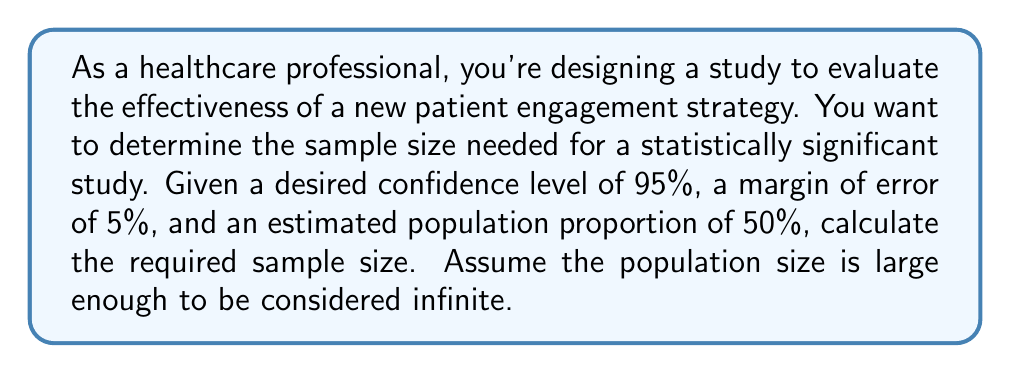Could you help me with this problem? To determine the sample size for a statistically significant study, we'll use the formula:

$$n = \frac{z^2 * p(1-p)}{e^2}$$

Where:
$n$ = sample size
$z$ = z-score (based on confidence level)
$p$ = estimated population proportion
$e$ = margin of error

Step 1: Determine the z-score for a 95% confidence level.
For 95% confidence, $z = 1.96$

Step 2: Convert the margin of error to a decimal.
$e = 5\% = 0.05$

Step 3: Use the estimated population proportion.
$p = 50\% = 0.5$

Step 4: Plug the values into the formula:

$$n = \frac{1.96^2 * 0.5(1-0.5)}{0.05^2}$$

Step 5: Calculate:

$$n = \frac{3.8416 * 0.25}{0.0025} = \frac{0.9604}{0.0025} = 384.16$$

Step 6: Round up to the nearest whole number, as we can't have a fractional sample size.

Therefore, the required sample size is 385.
Answer: 385 